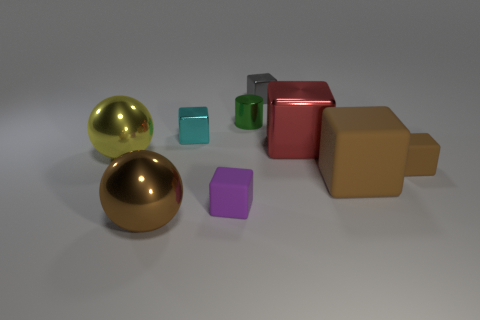Is the shape of the purple rubber thing that is in front of the large yellow metal object the same as the brown thing to the left of the cyan block?
Ensure brevity in your answer.  No. The large block that is the same material as the small brown block is what color?
Your response must be concise. Brown. There is a brown shiny sphere left of the big red metal block; is its size the same as the metallic block left of the small green cylinder?
Keep it short and to the point. No. The big thing that is in front of the big yellow thing and left of the small purple cube has what shape?
Your answer should be compact. Sphere. Is there a large blue sphere made of the same material as the red thing?
Your answer should be compact. No. What is the material of the big ball that is the same color as the big rubber block?
Make the answer very short. Metal. Does the large brown thing that is to the right of the cyan block have the same material as the tiny object to the right of the red object?
Provide a succinct answer. Yes. Is the number of red metal blocks greater than the number of red metallic cylinders?
Your answer should be very brief. Yes. What is the color of the tiny shiny cube in front of the tiny cube that is behind the small shiny thing in front of the green metal cylinder?
Your response must be concise. Cyan. There is a small metal block on the right side of the green shiny cylinder; does it have the same color as the large sphere right of the large yellow shiny sphere?
Provide a succinct answer. No. 